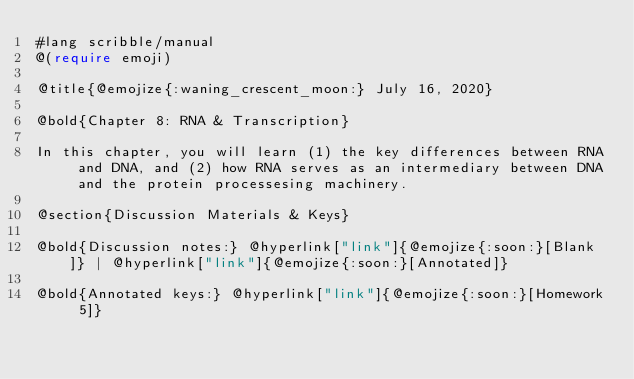<code> <loc_0><loc_0><loc_500><loc_500><_Racket_>#lang scribble/manual
@(require emoji)

@title{@emojize{:waning_crescent_moon:} July 16, 2020}

@bold{Chapter 8: RNA & Transcription}

In this chapter, you will learn (1) the key differences between RNA and DNA, and (2) how RNA serves as an intermediary between DNA and the protein processesing machinery.

@section{Discussion Materials & Keys}

@bold{Discussion notes:} @hyperlink["link"]{@emojize{:soon:}[Blank]} | @hyperlink["link"]{@emojize{:soon:}[Annotated]}

@bold{Annotated keys:} @hyperlink["link"]{@emojize{:soon:}[Homework 5]}
</code> 